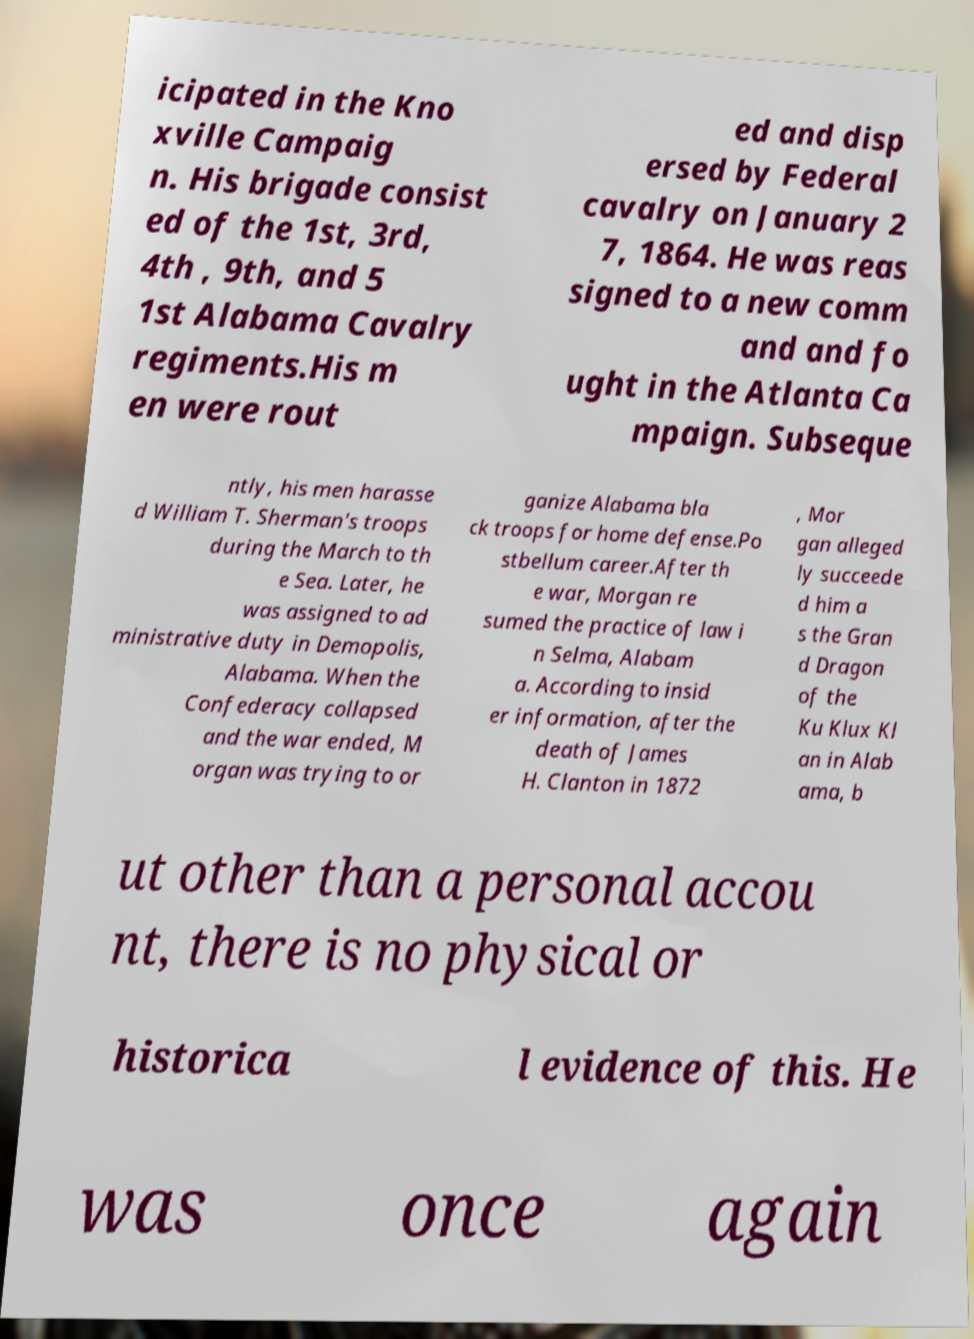Please identify and transcribe the text found in this image. icipated in the Kno xville Campaig n. His brigade consist ed of the 1st, 3rd, 4th , 9th, and 5 1st Alabama Cavalry regiments.His m en were rout ed and disp ersed by Federal cavalry on January 2 7, 1864. He was reas signed to a new comm and and fo ught in the Atlanta Ca mpaign. Subseque ntly, his men harasse d William T. Sherman's troops during the March to th e Sea. Later, he was assigned to ad ministrative duty in Demopolis, Alabama. When the Confederacy collapsed and the war ended, M organ was trying to or ganize Alabama bla ck troops for home defense.Po stbellum career.After th e war, Morgan re sumed the practice of law i n Selma, Alabam a. According to insid er information, after the death of James H. Clanton in 1872 , Mor gan alleged ly succeede d him a s the Gran d Dragon of the Ku Klux Kl an in Alab ama, b ut other than a personal accou nt, there is no physical or historica l evidence of this. He was once again 